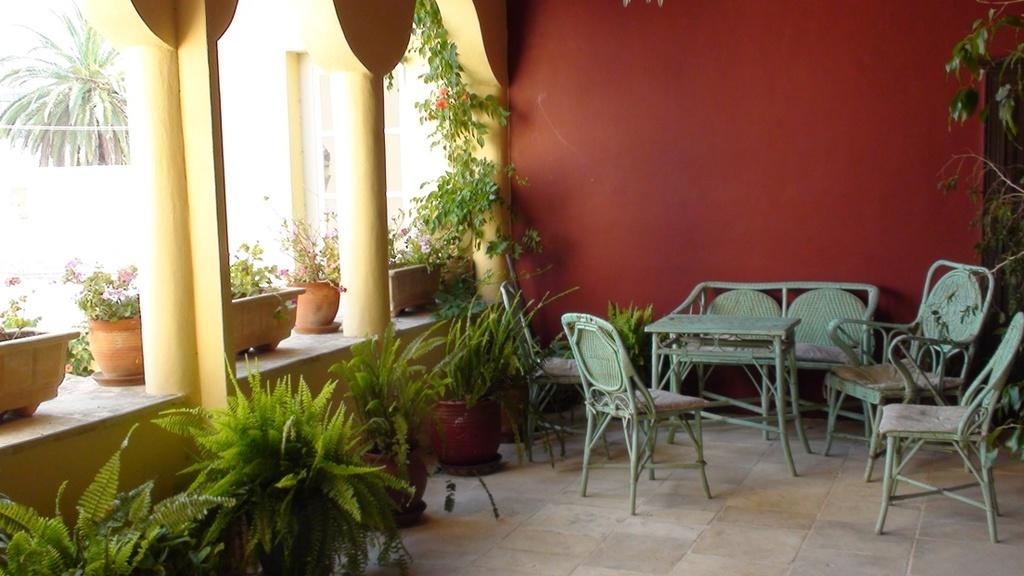Where is the setting of the image? The image is set in a home. What piece of furniture can be seen on the floor? There is a table on the floor. Are there any seating options in the image? Yes, there are chairs in the image. What type of decorative items are present in the image? Flower pots are present. What color is the wall in the image? The wall is red. What color is the pillar in the image? The pillar is yellow. What type of shirt is the pump wearing in the image? There is no pump or person wearing a shirt in the image. 